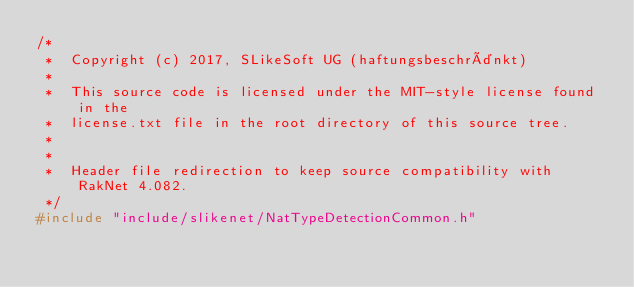Convert code to text. <code><loc_0><loc_0><loc_500><loc_500><_C_>/*
 *  Copyright (c) 2017, SLikeSoft UG (haftungsbeschränkt)
 *
 *  This source code is licensed under the MIT-style license found in the
 *  license.txt file in the root directory of this source tree.
 *
 *
 *  Header file redirection to keep source compatibility with RakNet 4.082.
 */
#include "include/slikenet/NatTypeDetectionCommon.h"
</code> 